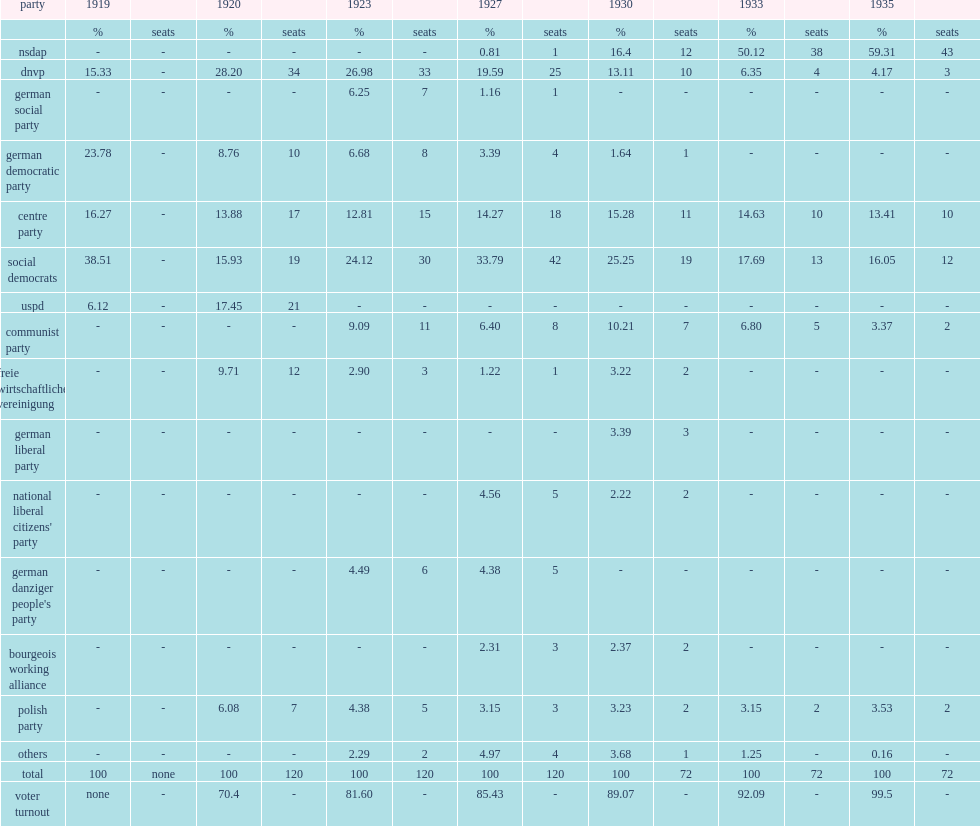What percent of the volkstag election votes is for the nazi party? 59.31. 